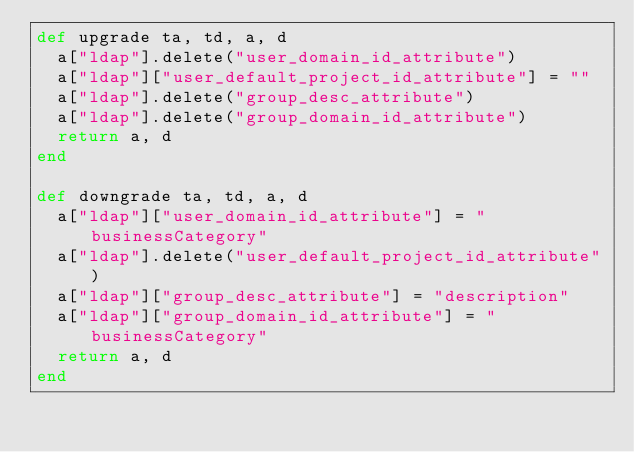Convert code to text. <code><loc_0><loc_0><loc_500><loc_500><_Ruby_>def upgrade ta, td, a, d
  a["ldap"].delete("user_domain_id_attribute")
  a["ldap"]["user_default_project_id_attribute"] = ""
  a["ldap"].delete("group_desc_attribute")
  a["ldap"].delete("group_domain_id_attribute")
  return a, d
end

def downgrade ta, td, a, d
  a["ldap"]["user_domain_id_attribute"] = "businessCategory"
  a["ldap"].delete("user_default_project_id_attribute")
  a["ldap"]["group_desc_attribute"] = "description"
  a["ldap"]["group_domain_id_attribute"] = "businessCategory"
  return a, d
end
</code> 